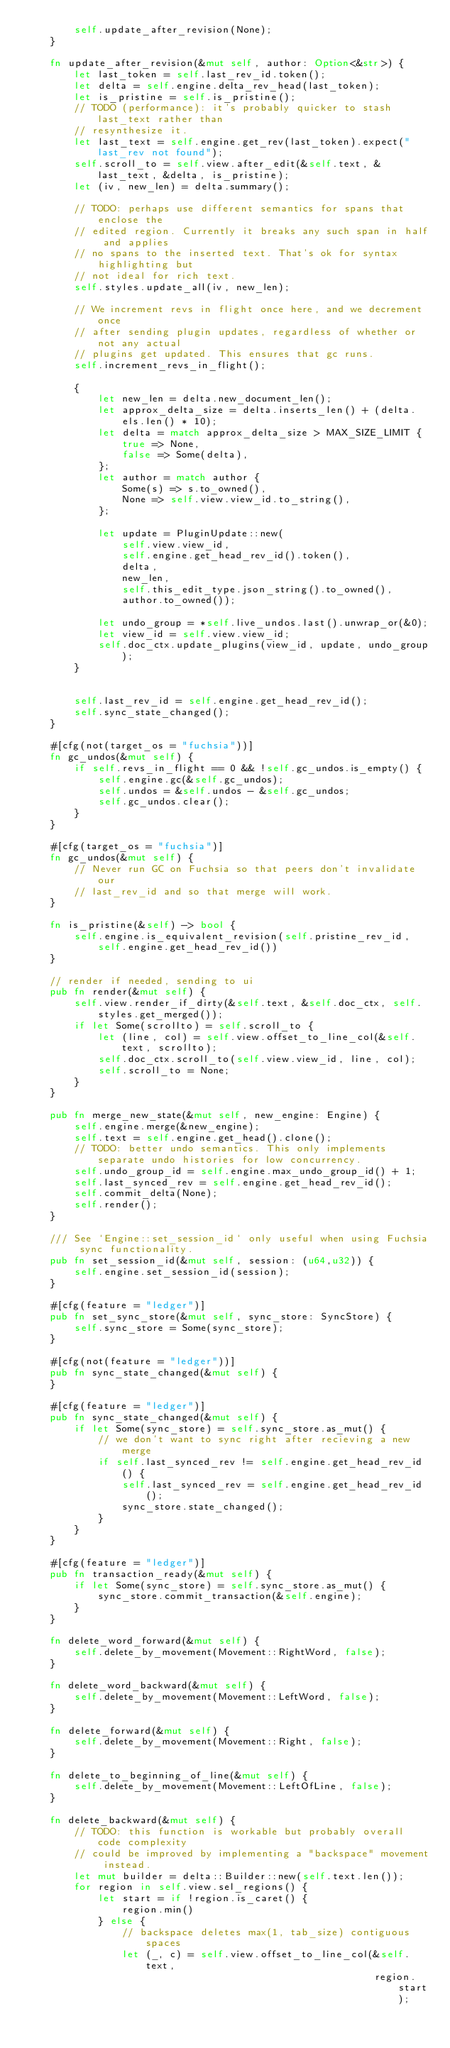<code> <loc_0><loc_0><loc_500><loc_500><_Rust_>        self.update_after_revision(None);
    }

    fn update_after_revision(&mut self, author: Option<&str>) {
        let last_token = self.last_rev_id.token();
        let delta = self.engine.delta_rev_head(last_token);
        let is_pristine = self.is_pristine();
        // TODO (performance): it's probably quicker to stash last_text rather than
        // resynthesize it.
        let last_text = self.engine.get_rev(last_token).expect("last_rev not found");
        self.scroll_to = self.view.after_edit(&self.text, &last_text, &delta, is_pristine);
        let (iv, new_len) = delta.summary();

        // TODO: perhaps use different semantics for spans that enclose the
        // edited region. Currently it breaks any such span in half and applies
        // no spans to the inserted text. That's ok for syntax highlighting but
        // not ideal for rich text.
        self.styles.update_all(iv, new_len);

        // We increment revs in flight once here, and we decrement once
        // after sending plugin updates, regardless of whether or not any actual
        // plugins get updated. This ensures that gc runs.
        self.increment_revs_in_flight();

        {
            let new_len = delta.new_document_len();
            let approx_delta_size = delta.inserts_len() + (delta.els.len() * 10);
            let delta = match approx_delta_size > MAX_SIZE_LIMIT {
                true => None,
                false => Some(delta),
            };
            let author = match author {
                Some(s) => s.to_owned(),
                None => self.view.view_id.to_string(),
            };

            let update = PluginUpdate::new(
                self.view.view_id,
                self.engine.get_head_rev_id().token(),
                delta,
                new_len,
                self.this_edit_type.json_string().to_owned(),
                author.to_owned());

            let undo_group = *self.live_undos.last().unwrap_or(&0);
            let view_id = self.view.view_id;
            self.doc_ctx.update_plugins(view_id, update, undo_group);
        }


        self.last_rev_id = self.engine.get_head_rev_id();
        self.sync_state_changed();
    }

    #[cfg(not(target_os = "fuchsia"))]
    fn gc_undos(&mut self) {
        if self.revs_in_flight == 0 && !self.gc_undos.is_empty() {
            self.engine.gc(&self.gc_undos);
            self.undos = &self.undos - &self.gc_undos;
            self.gc_undos.clear();
        }
    }

    #[cfg(target_os = "fuchsia")]
    fn gc_undos(&mut self) {
        // Never run GC on Fuchsia so that peers don't invalidate our
        // last_rev_id and so that merge will work.
    }

    fn is_pristine(&self) -> bool {
        self.engine.is_equivalent_revision(self.pristine_rev_id, self.engine.get_head_rev_id())
    }

    // render if needed, sending to ui
    pub fn render(&mut self) {
        self.view.render_if_dirty(&self.text, &self.doc_ctx, self.styles.get_merged());
        if let Some(scrollto) = self.scroll_to {
            let (line, col) = self.view.offset_to_line_col(&self.text, scrollto);
            self.doc_ctx.scroll_to(self.view.view_id, line, col);
            self.scroll_to = None;
        }
    }

    pub fn merge_new_state(&mut self, new_engine: Engine) {
        self.engine.merge(&new_engine);
        self.text = self.engine.get_head().clone();
        // TODO: better undo semantics. This only implements separate undo histories for low concurrency.
        self.undo_group_id = self.engine.max_undo_group_id() + 1;
        self.last_synced_rev = self.engine.get_head_rev_id();
        self.commit_delta(None);
        self.render();
    }

    /// See `Engine::set_session_id` only useful when using Fuchsia sync functionality.
    pub fn set_session_id(&mut self, session: (u64,u32)) {
        self.engine.set_session_id(session);
    }

    #[cfg(feature = "ledger")]
    pub fn set_sync_store(&mut self, sync_store: SyncStore) {
        self.sync_store = Some(sync_store);
    }

    #[cfg(not(feature = "ledger"))]
    pub fn sync_state_changed(&mut self) {
    }

    #[cfg(feature = "ledger")]
    pub fn sync_state_changed(&mut self) {
        if let Some(sync_store) = self.sync_store.as_mut() {
            // we don't want to sync right after recieving a new merge
            if self.last_synced_rev != self.engine.get_head_rev_id() {
                self.last_synced_rev = self.engine.get_head_rev_id();
                sync_store.state_changed();
            }
        }
    }

    #[cfg(feature = "ledger")]
    pub fn transaction_ready(&mut self) {
        if let Some(sync_store) = self.sync_store.as_mut() {
            sync_store.commit_transaction(&self.engine);
        }
    }

    fn delete_word_forward(&mut self) {
        self.delete_by_movement(Movement::RightWord, false);
    }

    fn delete_word_backward(&mut self) {
        self.delete_by_movement(Movement::LeftWord, false);
    }

    fn delete_forward(&mut self) {
        self.delete_by_movement(Movement::Right, false);
    }

    fn delete_to_beginning_of_line(&mut self) {
        self.delete_by_movement(Movement::LeftOfLine, false);
    }

    fn delete_backward(&mut self) {
        // TODO: this function is workable but probably overall code complexity
        // could be improved by implementing a "backspace" movement instead.
        let mut builder = delta::Builder::new(self.text.len());
        for region in self.view.sel_regions() {
            let start = if !region.is_caret() {
                region.min()
            } else {
                // backspace deletes max(1, tab_size) contiguous spaces
                let (_, c) = self.view.offset_to_line_col(&self.text,
                                                          region.start);</code> 